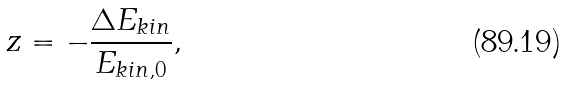Convert formula to latex. <formula><loc_0><loc_0><loc_500><loc_500>z = - \frac { \Delta E _ { k i n } } { E _ { k i n , 0 } } ,</formula> 